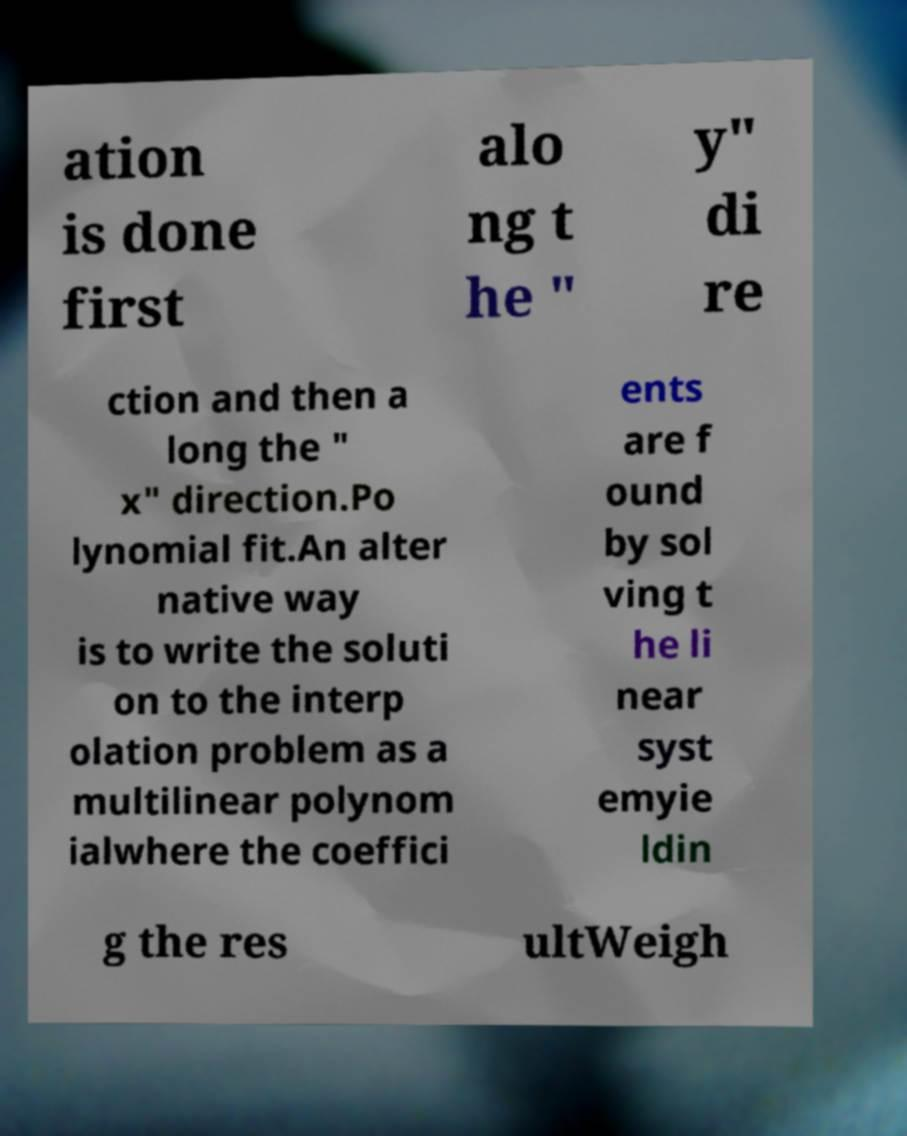Can you accurately transcribe the text from the provided image for me? ation is done first alo ng t he " y" di re ction and then a long the " x" direction.Po lynomial fit.An alter native way is to write the soluti on to the interp olation problem as a multilinear polynom ialwhere the coeffici ents are f ound by sol ving t he li near syst emyie ldin g the res ultWeigh 